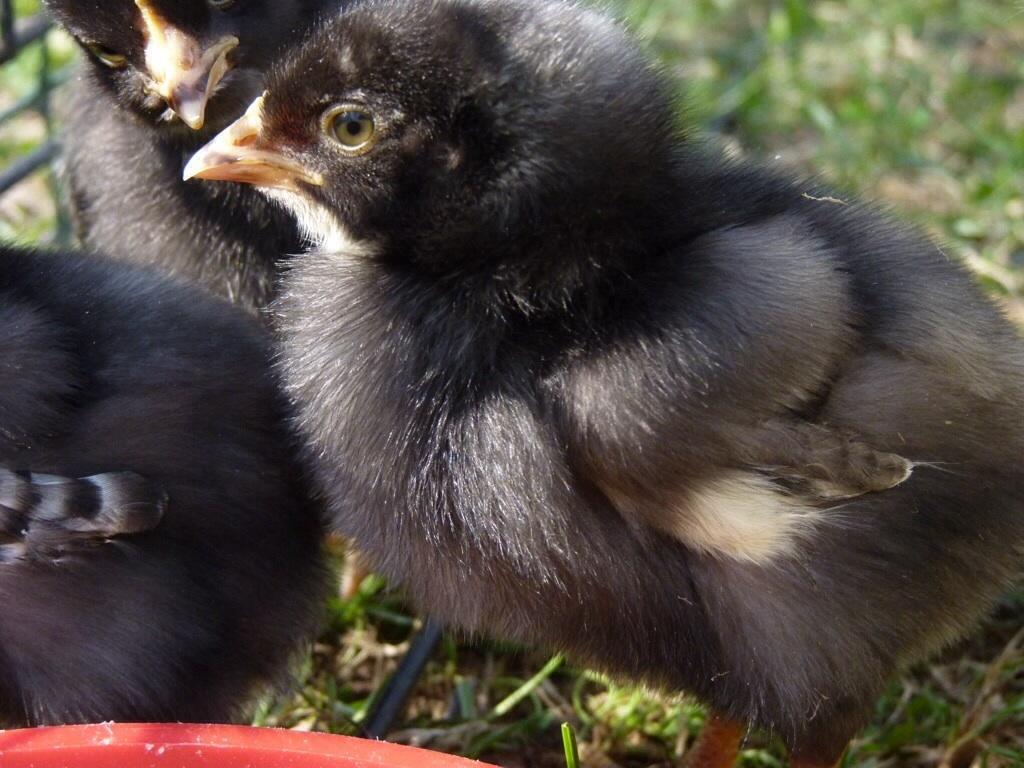Could you give a brief overview of what you see in this image? In this image we can see some birds on the grass and also we can see the fence. 